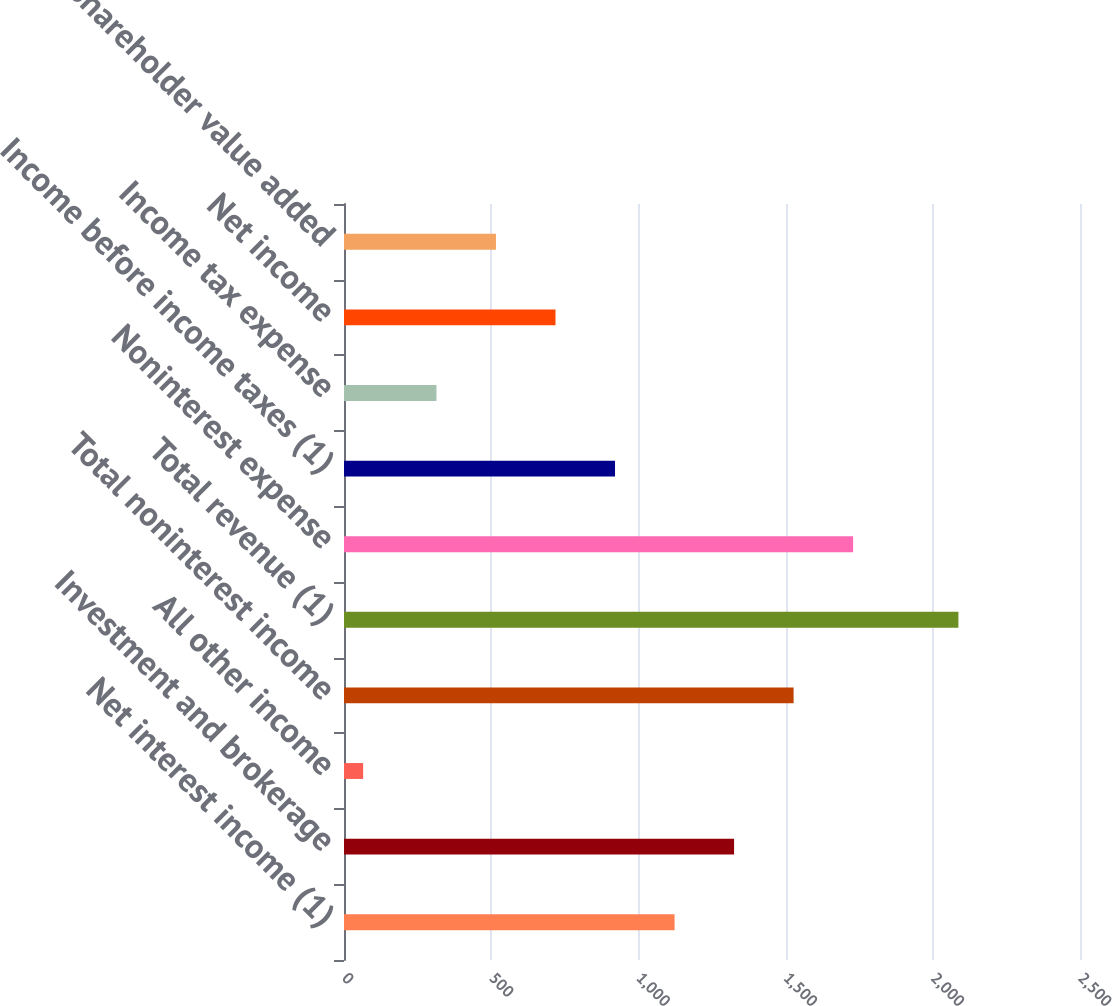Convert chart to OTSL. <chart><loc_0><loc_0><loc_500><loc_500><bar_chart><fcel>Net interest income (1)<fcel>Investment and brokerage<fcel>All other income<fcel>Total noninterest income<fcel>Total revenue (1)<fcel>Noninterest expense<fcel>Income before income taxes (1)<fcel>Income tax expense<fcel>Net income<fcel>Shareholder value added<nl><fcel>1122.8<fcel>1325<fcel>65<fcel>1527.2<fcel>2087<fcel>1729.4<fcel>920.6<fcel>314<fcel>718.4<fcel>516.2<nl></chart> 